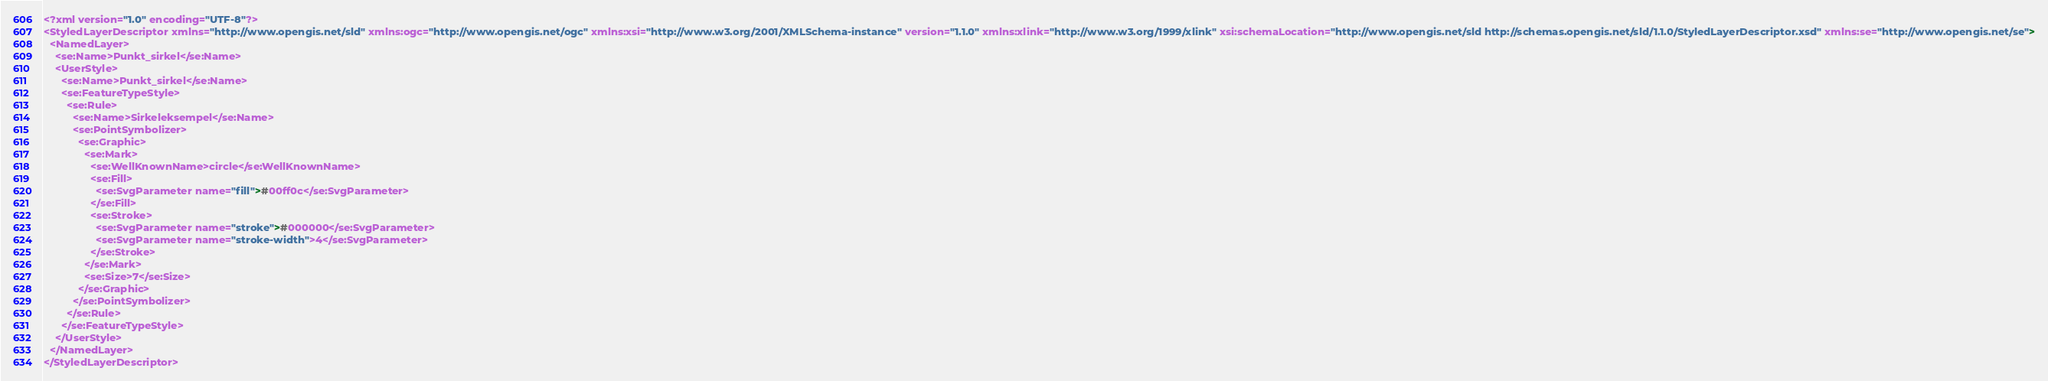<code> <loc_0><loc_0><loc_500><loc_500><_Scheme_><?xml version="1.0" encoding="UTF-8"?>
<StyledLayerDescriptor xmlns="http://www.opengis.net/sld" xmlns:ogc="http://www.opengis.net/ogc" xmlns:xsi="http://www.w3.org/2001/XMLSchema-instance" version="1.1.0" xmlns:xlink="http://www.w3.org/1999/xlink" xsi:schemaLocation="http://www.opengis.net/sld http://schemas.opengis.net/sld/1.1.0/StyledLayerDescriptor.xsd" xmlns:se="http://www.opengis.net/se">
  <NamedLayer>
    <se:Name>Punkt_sirkel</se:Name>
    <UserStyle>
      <se:Name>Punkt_sirkel</se:Name>
      <se:FeatureTypeStyle>
        <se:Rule>
          <se:Name>Sirkeleksempel</se:Name>
          <se:PointSymbolizer>
            <se:Graphic>
              <se:Mark>
                <se:WellKnownName>circle</se:WellKnownName>
                <se:Fill>
                  <se:SvgParameter name="fill">#00ff0c</se:SvgParameter>
                </se:Fill>
                <se:Stroke>
                  <se:SvgParameter name="stroke">#000000</se:SvgParameter>
				  <se:SvgParameter name="stroke-width">4</se:SvgParameter>
                </se:Stroke>
              </se:Mark>
              <se:Size>7</se:Size>
            </se:Graphic>
          </se:PointSymbolizer>
        </se:Rule>
      </se:FeatureTypeStyle>
    </UserStyle>
  </NamedLayer>
</StyledLayerDescriptor>
</code> 